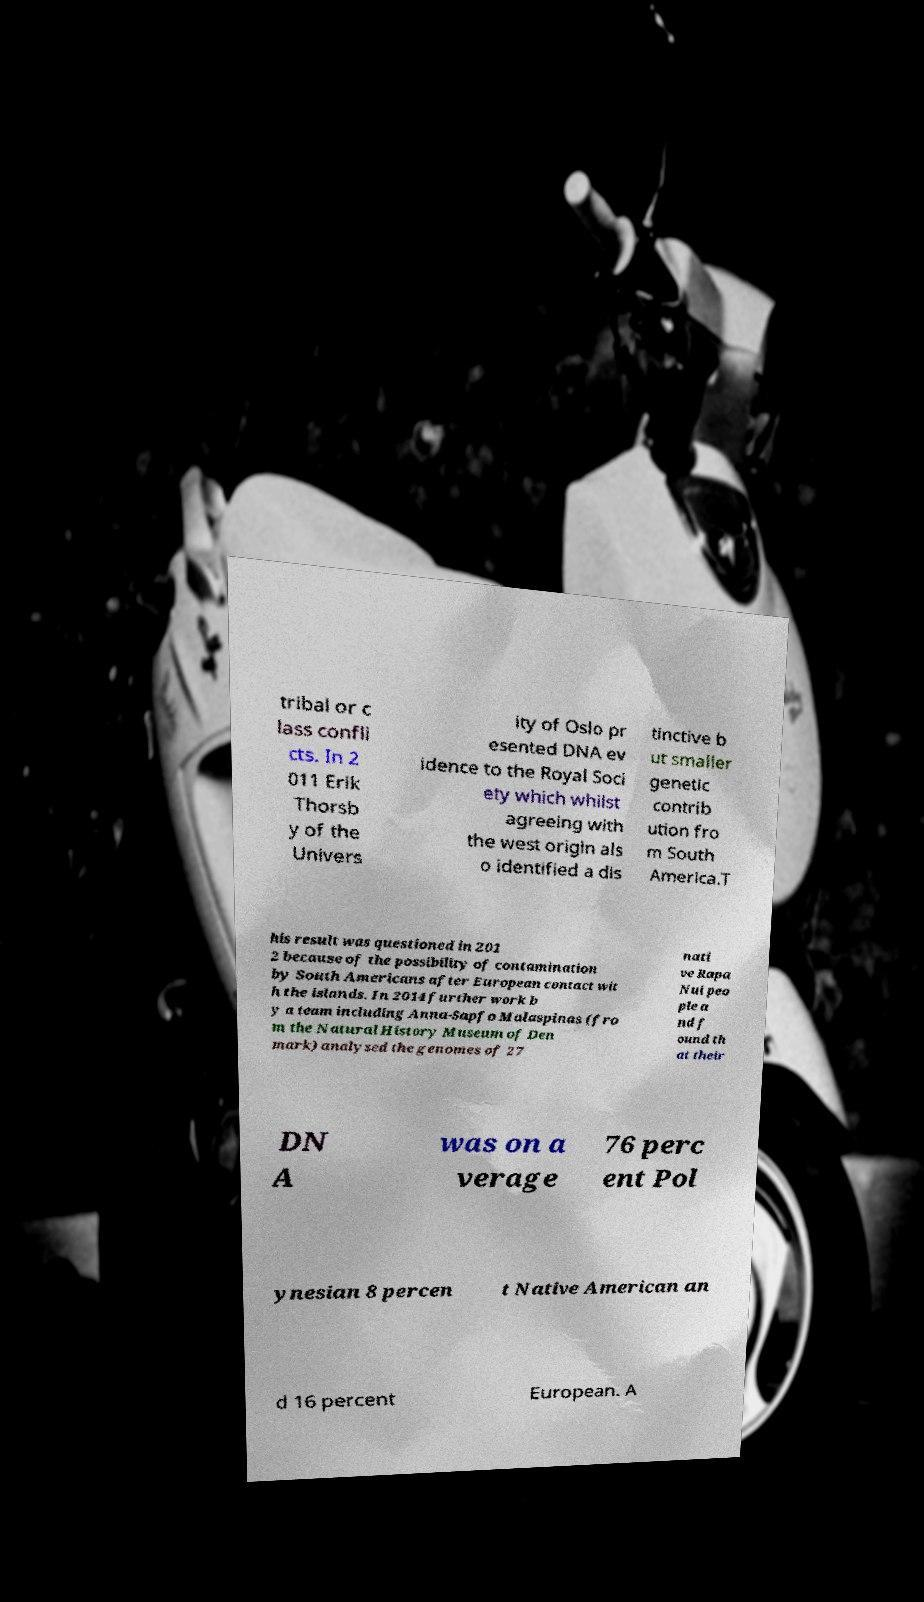Please read and relay the text visible in this image. What does it say? tribal or c lass confli cts. In 2 011 Erik Thorsb y of the Univers ity of Oslo pr esented DNA ev idence to the Royal Soci ety which whilst agreeing with the west origin als o identified a dis tinctive b ut smaller genetic contrib ution fro m South America.T his result was questioned in 201 2 because of the possibility of contamination by South Americans after European contact wit h the islands. In 2014 further work b y a team including Anna-Sapfo Malaspinas (fro m the Natural History Museum of Den mark) analysed the genomes of 27 nati ve Rapa Nui peo ple a nd f ound th at their DN A was on a verage 76 perc ent Pol ynesian 8 percen t Native American an d 16 percent European. A 